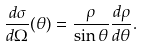<formula> <loc_0><loc_0><loc_500><loc_500>\frac { d \sigma } { d \Omega } ( \theta ) = \frac { \rho } { \sin \theta } \frac { d \rho } { d \theta } .</formula> 